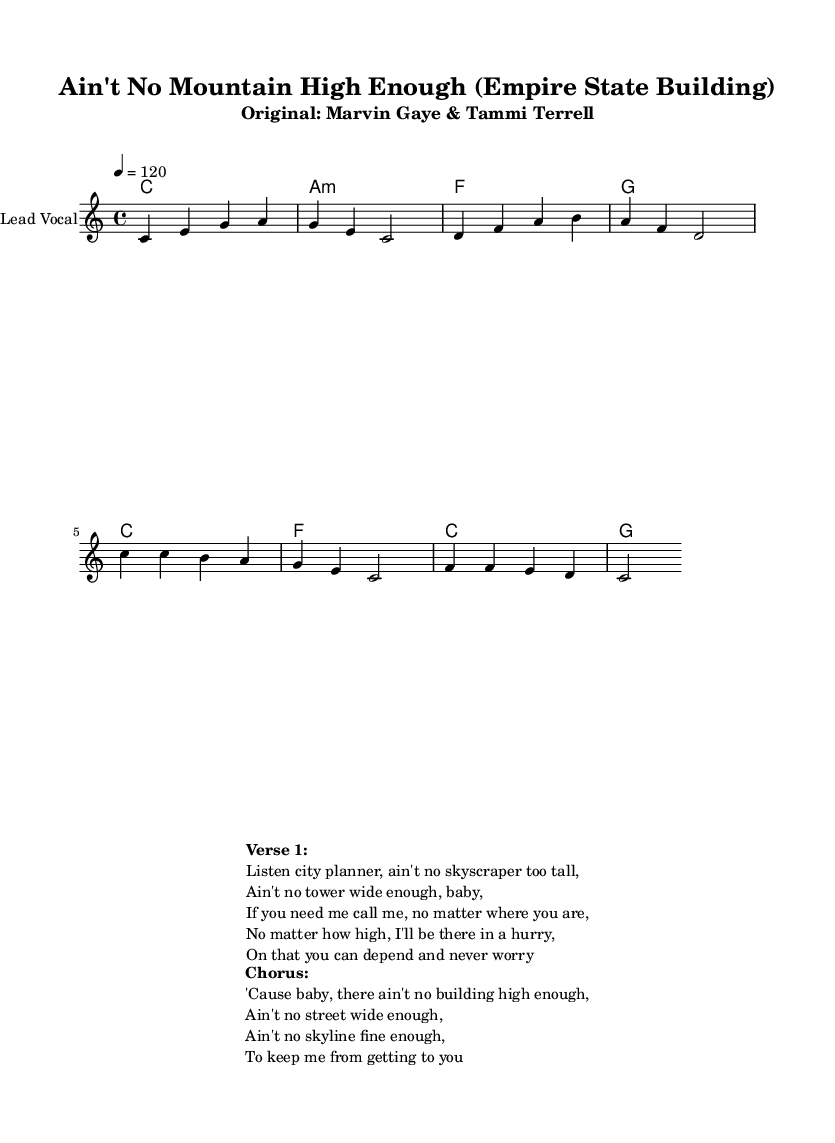What is the key signature of this music? The key signature is indicated at the beginning of the staff and shows no sharps or flats, denoting C major.
Answer: C major What is the time signature of this music? The time signature is represented as 4/4 at the beginning of the score, meaning there are four beats per measure and the quarter note gets one beat.
Answer: 4/4 What is the tempo marking for this piece? The tempo marking, indicated in text above the staff, is set to 120 beats per minute, which provides guidance on how fast the piece should be played.
Answer: 120 How many measures are in the verse section? By counting the bar lines in the verse section from the beginning to the end of that segment, we find there are four measures.
Answer: Four What is the primary theme of the lyrics? The lyrics center around skylines and the idea of reassurance in the context of urban structures, as articulated in the reimagined version of this Motown classic.
Answer: Skyscrapers How does the chorus relate to the theme of urban planning? The chorus reinforces the theme of accessibility and the idea that no matter how high or far structures may be, there remains a commitment to reach them, which reflects urban planning goals of connectivity and accessibility.
Answer: Accessibility What genre does this reimagined piece belong to? The style of this piece aligns with Rhythm and Blues, a genre characterized by a strong emotional expression and a blend of soul, jazz, and gospel elements, evident in the vocal and instrumental treatment.
Answer: Rhythm and Blues 